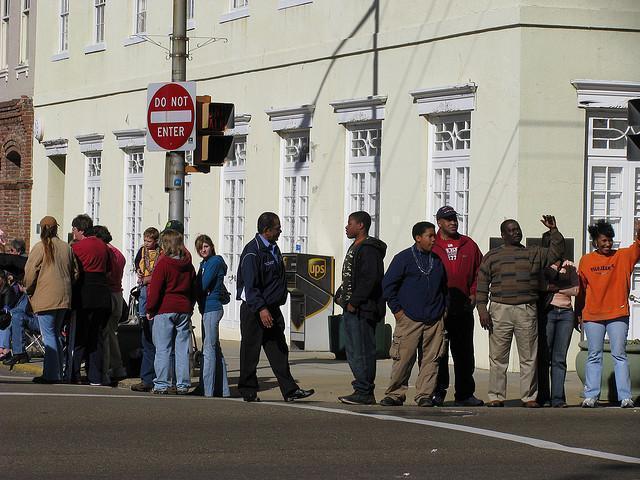What is under the red and white sign?
From the following four choices, select the correct answer to address the question.
Options: Boy, polar bear, seal, cat. Boy. 